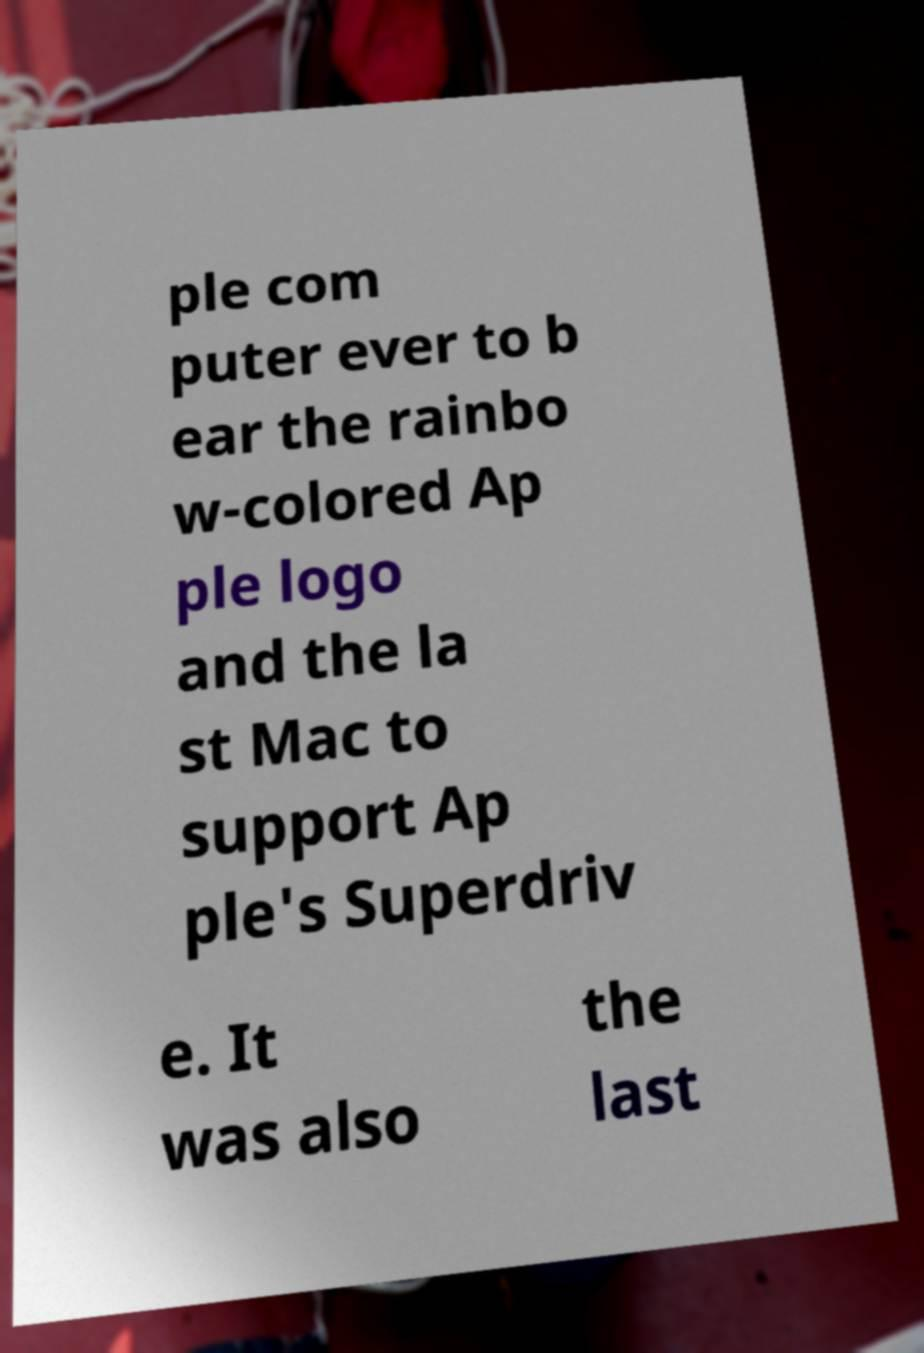There's text embedded in this image that I need extracted. Can you transcribe it verbatim? ple com puter ever to b ear the rainbo w-colored Ap ple logo and the la st Mac to support Ap ple's Superdriv e. It was also the last 